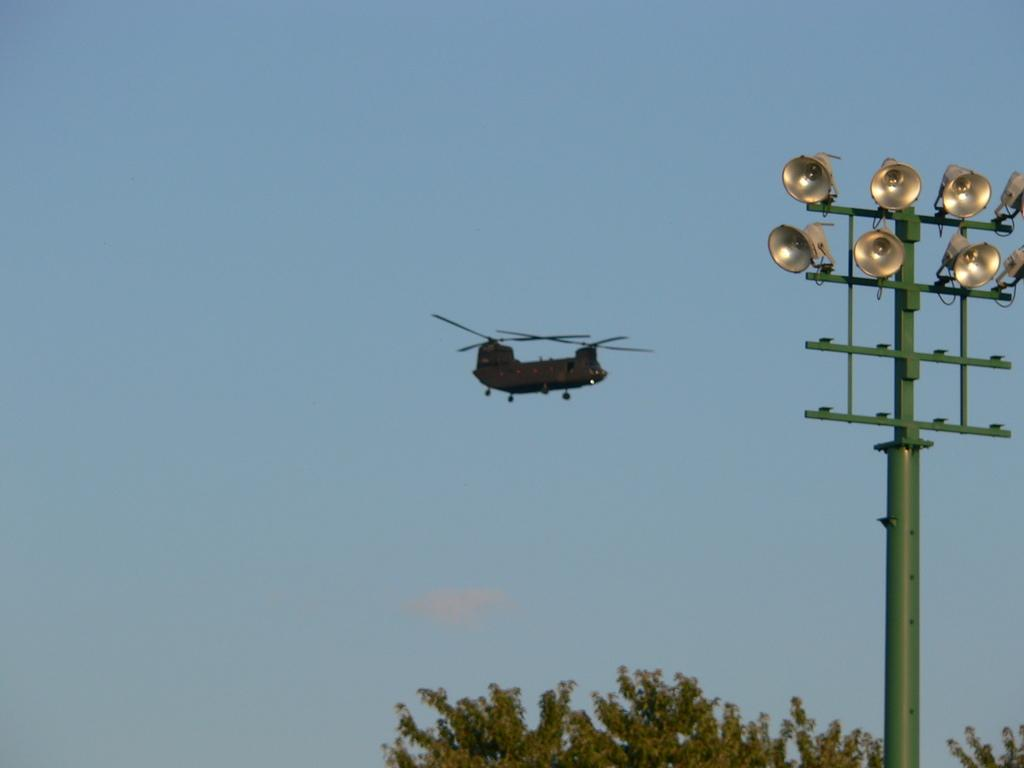What is the main subject of the image? The main subject of the image is a helicopter. Where is the helicopter located in the image? The helicopter is in the air. What can be seen below the helicopter? There are trees below the helicopter. What structure is present in the image? There is a pole with lights in the image. What is visible above the helicopter? The sky is visible above the helicopter. What type of hope can be seen growing on the trees below the helicopter? There is no mention of hope or any plant life in the image; it only features a helicopter, trees, a pole with lights, and the sky. 